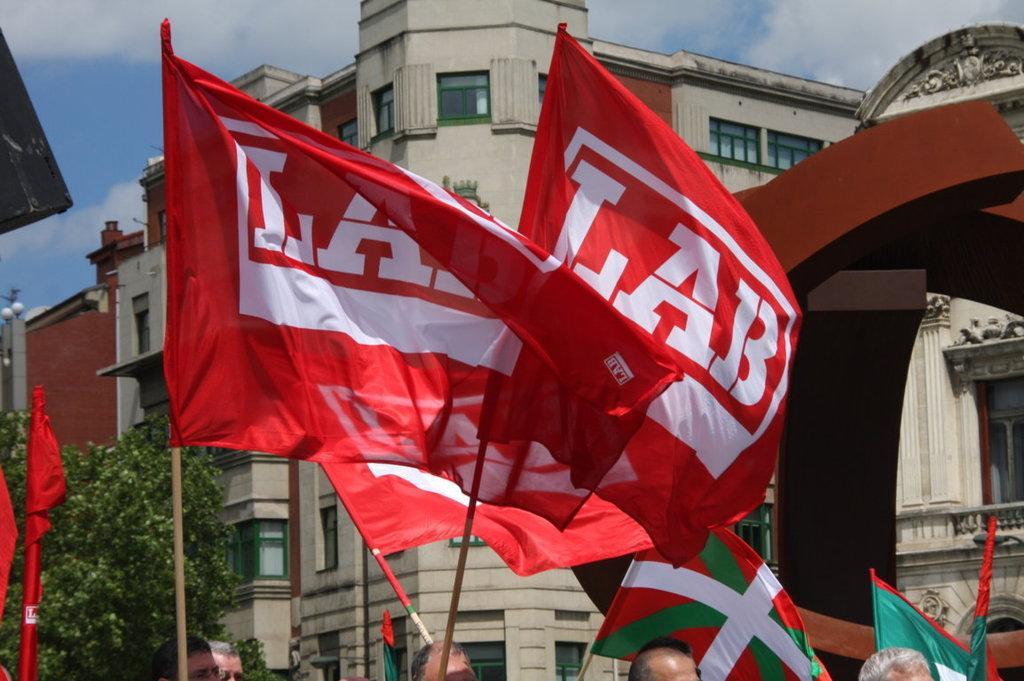How would you summarize this image in a sentence or two? In this image I can see few flags in red, white and green. In the background I can see few buildings, trees in green color and the sky is in blue and white color. 